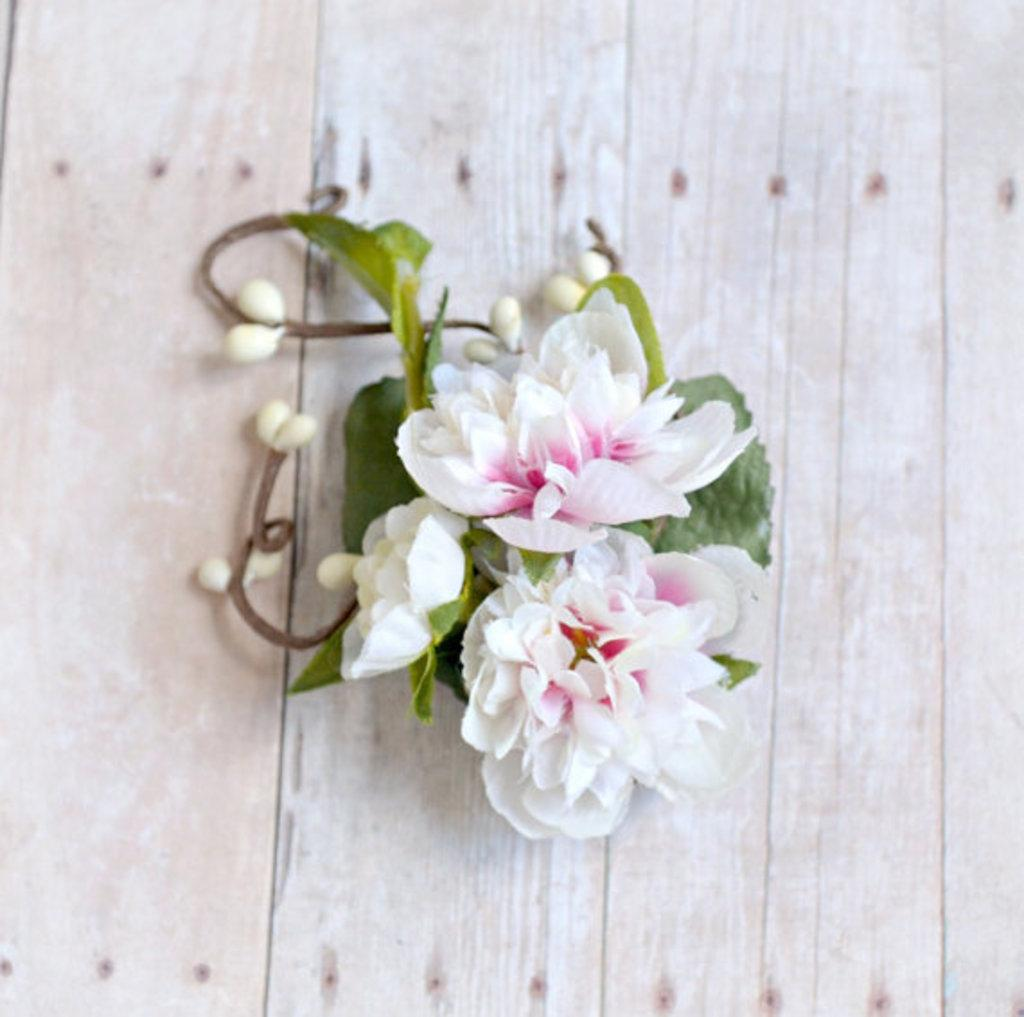What type of plants can be seen in the image? There are flowers and leaves in the image. What is the surface on which the flowers and leaves are placed? The flowers and leaves are on a wooden surface. What type of committee is responsible for maintaining the wilderness in the image? There is no committee or wilderness present in the image; it features flowers and leaves on a wooden surface. 